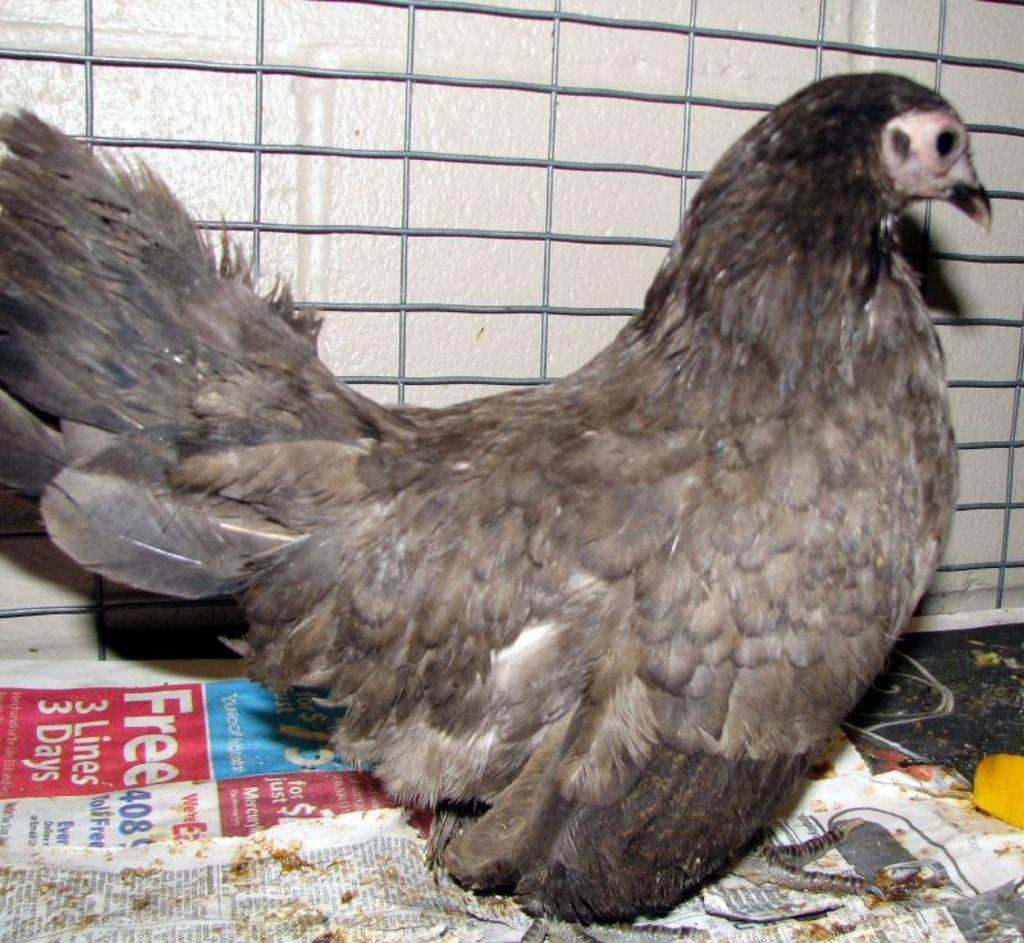What type of animal is in the cage in the image? There is a bird in a cage in the image. What can be seen besides the bird and its cage? There are newspapers in the image. What type of circle can be seen on the bird's head in the image? There is no circle on the bird's head in the image. How many books are visible in the image? There are no books visible in the image; only newspapers are present. 